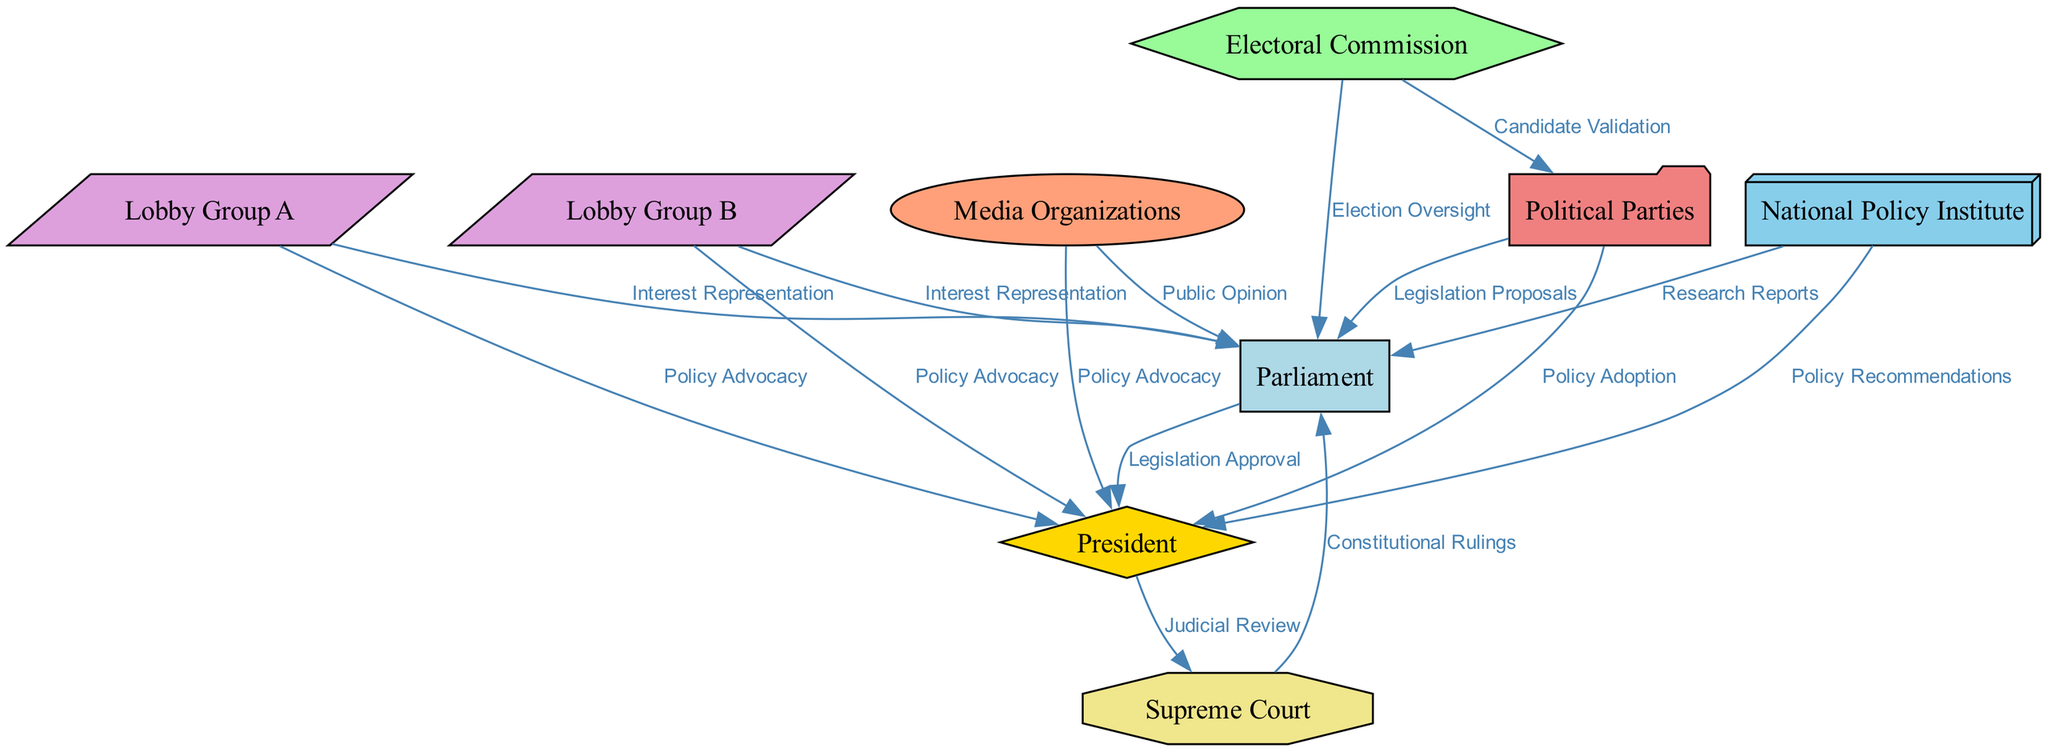What is the total number of nodes in the diagram? The diagram lists nine distinct entities, which include various political institutions, lobby groups, media organizations, and electoral bodies. Each of these is represented as a separate node.
Answer: 9 Which institution has the role of Electoral Oversight? In the diagram, the Electoral Commission is specified as the body responsible for overseeing elections, indicated by the edge labeled "Election Oversight" connecting it to Parliament.
Answer: Electoral Commission What is the relationship between the President and the Supreme Court? The President is connected to the Supreme Court through the edge labeled "Judicial Review," which signifies a direct influence of the President over Supreme Court actions.
Answer: Judicial Review How many edges connect the Media Organizations to other nodes? By examining the edges tied to Media Organizations, there are two distinct connections: one to Parliament (Public Opinion) and one to the President (Policy Advocacy). Hence, it connects to two nodes.
Answer: 2 Which lobby group advocates for policies toward both the Parliament and the President? Lobby Group A has connections to both the Parliament for "Interest Representation" and the President for "Policy Advocacy," indicating its dual role in influencing both entities.
Answer: Lobby Group A What is the nature of the edges between the Political Parties and the Electoral Commission? The edges specifically outline two connections: one for "Candidate Validation" from the Electoral Commission to Political Parties, and another for "Legislation Proposals" from the Political Parties to the Parliament, emphasizing their interrelated roles within the electoral process.
Answer: Candidate Validation Which node has incoming edges from both the National Policy Institute and the Media Organizations? The Parliament receives edges from two sources: the National Policy Institute with the label "Research Reports" and the Media Organizations with "Public Opinion." This illustrates how both research and media influence the Parliament.
Answer: Parliament What is the label of the edge connecting Lobby Group B to the Parliament? Lobby Group B is linked to the Parliament by an edge labeled "Interest Representation," which indicates its role in advocating for specific interests within the legislative body.
Answer: Interest Representation How many edges are directed towards the President? The President has edges directed towards it from both the Parliament (Legislation Approval) and lobby groups, as well as the media for advocacy. A careful count shows that there are six edges connecting to the President from various entities.
Answer: 6 